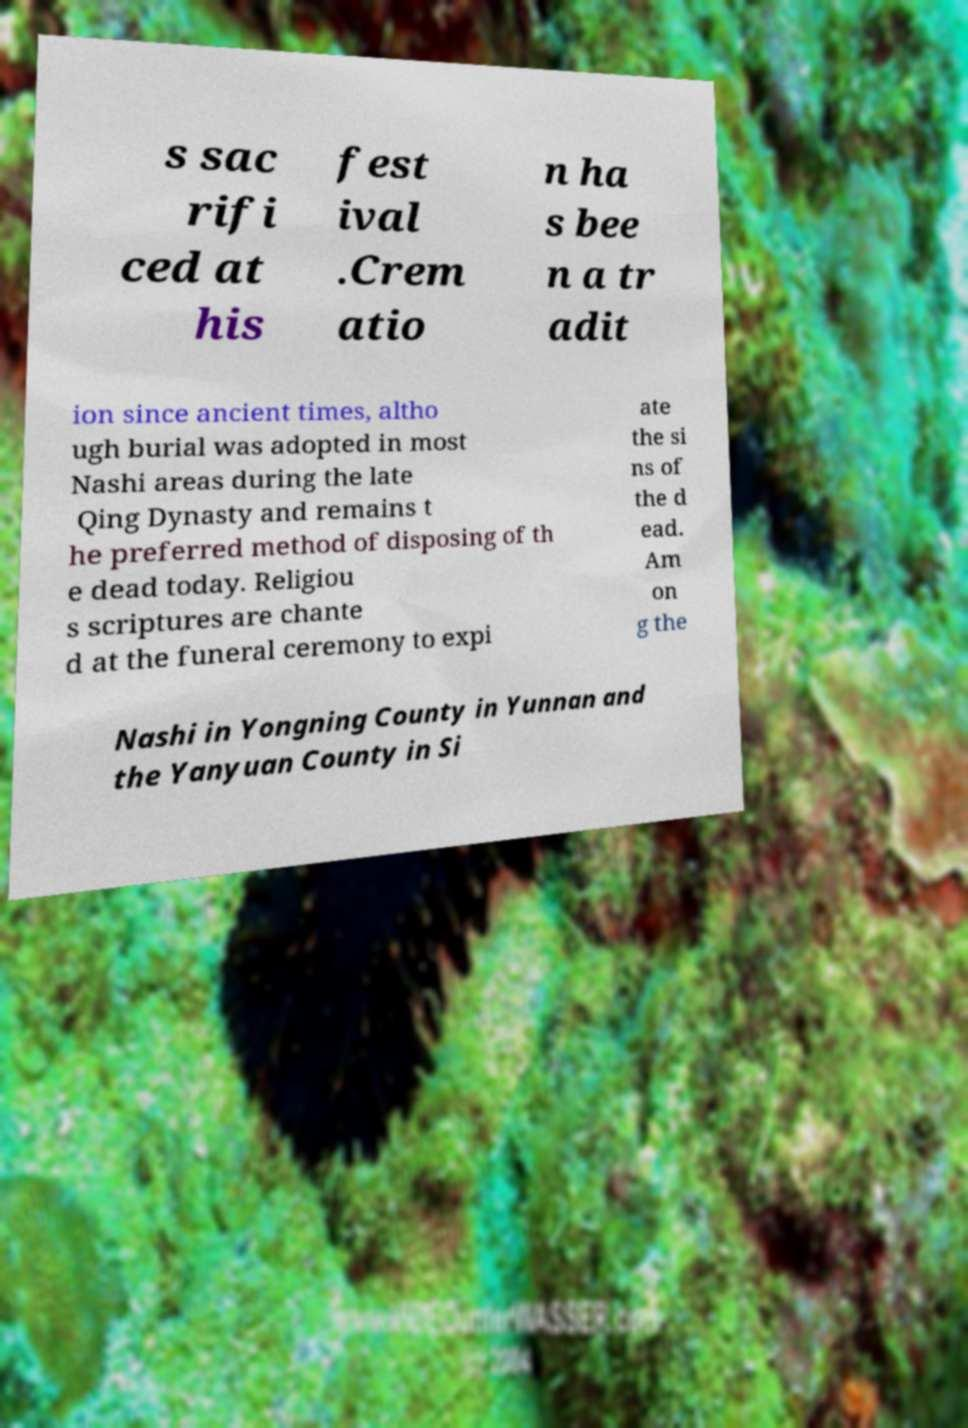Could you extract and type out the text from this image? s sac rifi ced at his fest ival .Crem atio n ha s bee n a tr adit ion since ancient times, altho ugh burial was adopted in most Nashi areas during the late Qing Dynasty and remains t he preferred method of disposing of th e dead today. Religiou s scriptures are chante d at the funeral ceremony to expi ate the si ns of the d ead. Am on g the Nashi in Yongning County in Yunnan and the Yanyuan County in Si 